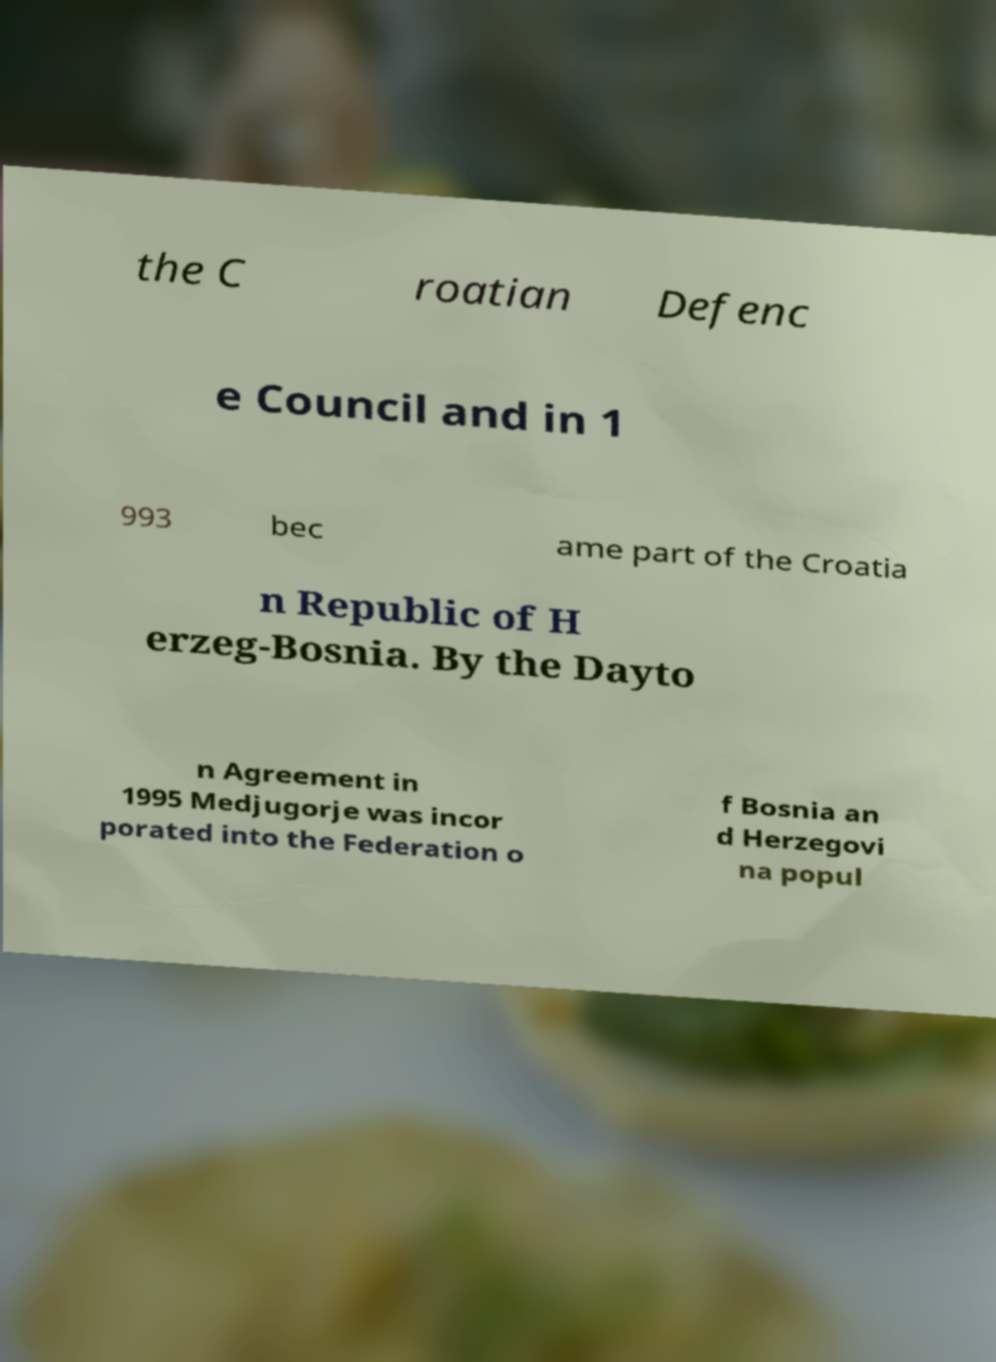What messages or text are displayed in this image? I need them in a readable, typed format. the C roatian Defenc e Council and in 1 993 bec ame part of the Croatia n Republic of H erzeg-Bosnia. By the Dayto n Agreement in 1995 Medjugorje was incor porated into the Federation o f Bosnia an d Herzegovi na popul 